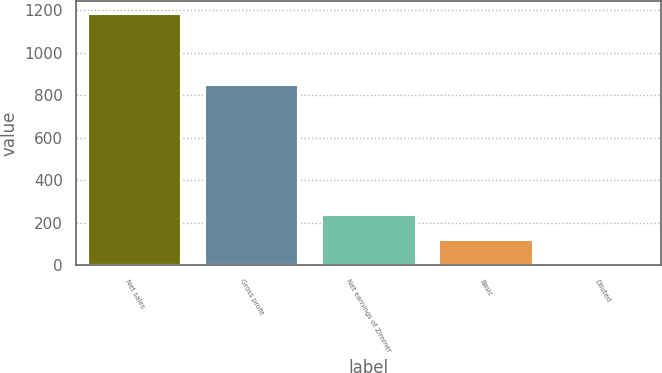Convert chart to OTSL. <chart><loc_0><loc_0><loc_500><loc_500><bar_chart><fcel>Net sales<fcel>Gross profit<fcel>Net earnings of Zimmer<fcel>Basic<fcel>Diluted<nl><fcel>1182.9<fcel>849.7<fcel>237.41<fcel>119.22<fcel>1.03<nl></chart> 